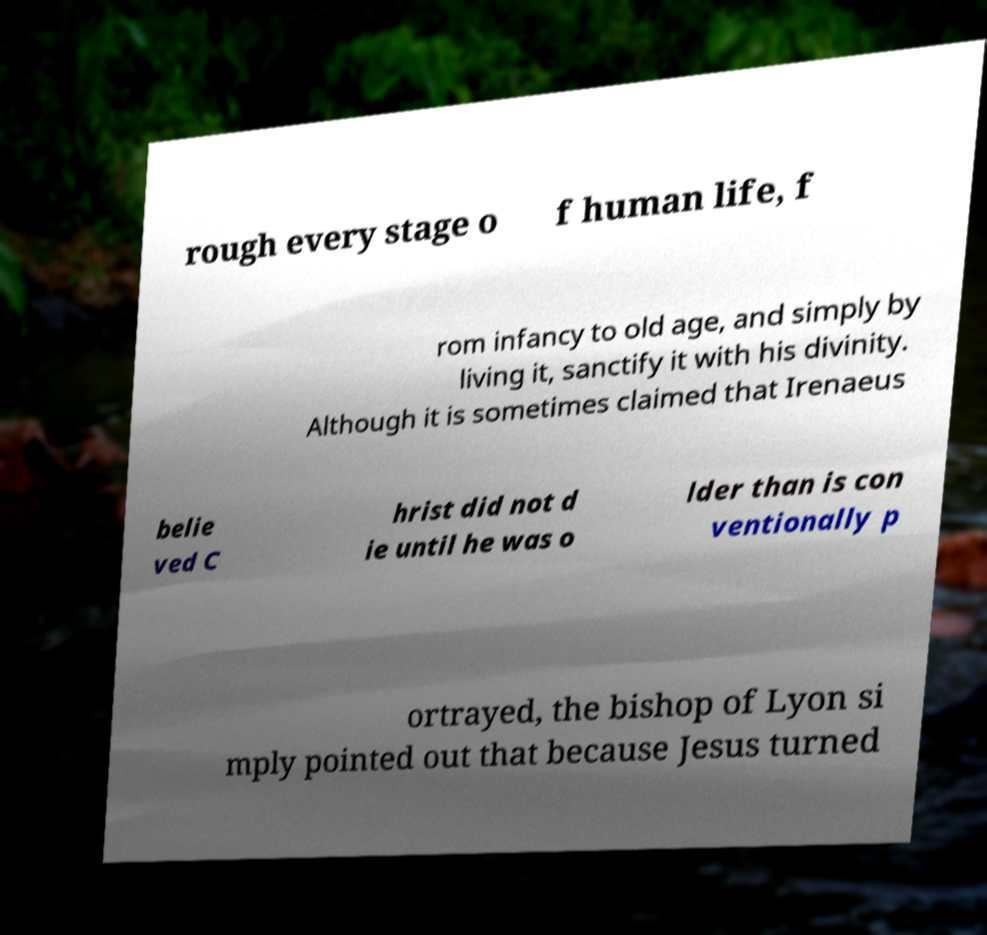I need the written content from this picture converted into text. Can you do that? rough every stage o f human life, f rom infancy to old age, and simply by living it, sanctify it with his divinity. Although it is sometimes claimed that Irenaeus belie ved C hrist did not d ie until he was o lder than is con ventionally p ortrayed, the bishop of Lyon si mply pointed out that because Jesus turned 